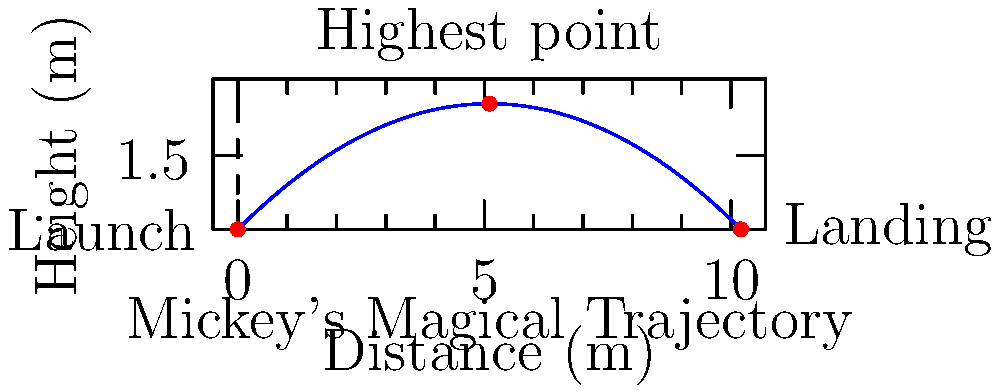In Mickey's Carnival at Disney World, Goofy launches a foam ball from his wacky contraption. The ball follows the path shown in the diagram. If the initial velocity is 10 m/s at a 45-degree angle, what is the maximum height (H) reached by the ball? Let's approach this step-by-step:

1) The maximum height in projectile motion is given by the formula:

   $H = \frac{v_0^2 \sin^2 \theta}{2g}$

   Where:
   $v_0$ is the initial velocity
   $\theta$ is the launch angle
   $g$ is the acceleration due to gravity (9.8 m/s²)

2) We're given:
   $v_0 = 10$ m/s
   $\theta = 45°$ (which is $\frac{\pi}{4}$ radians)

3) Let's substitute these values:

   $H = \frac{(10 \text{ m/s})^2 \sin^2(45°)}{2(9.8 \text{ m/s}^2)}$

4) Simplify:
   $\sin 45° = \frac{\sqrt{2}}{2}$, so $\sin^2 45° = \frac{1}{2}$

   $H = \frac{100 \text{ m}^2/\text{s}^2 \cdot \frac{1}{2}}{2(9.8 \text{ m/s}^2)}$

5) Calculate:

   $H = \frac{50 \text{ m}^2/\text{s}^2}{19.6 \text{ m/s}^2} = 2.55 \text{ m}$

Therefore, the maximum height reached by the foam ball is approximately 2.55 meters.
Answer: 2.55 m 